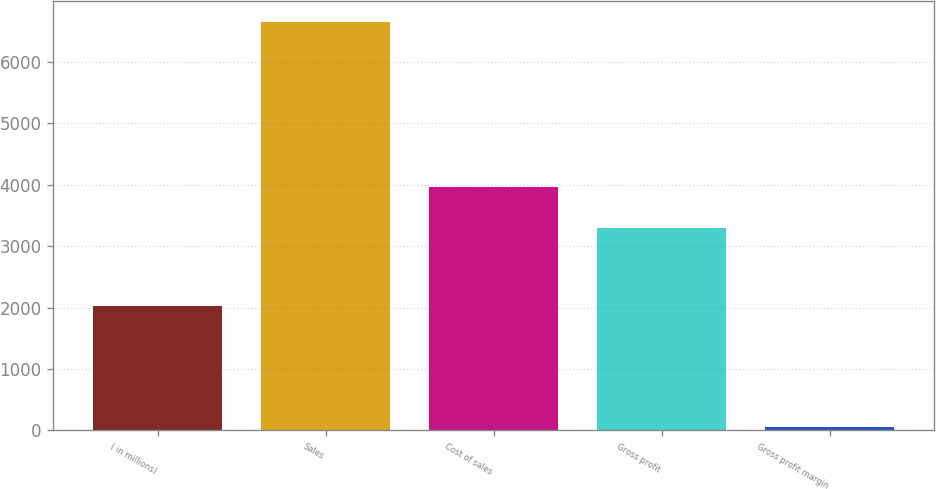Convert chart to OTSL. <chart><loc_0><loc_0><loc_500><loc_500><bar_chart><fcel>( in millions)<fcel>Sales<fcel>Cost of sales<fcel>Gross profit<fcel>Gross profit margin<nl><fcel>2017<fcel>6656<fcel>3959.14<fcel>3298.5<fcel>49.6<nl></chart> 